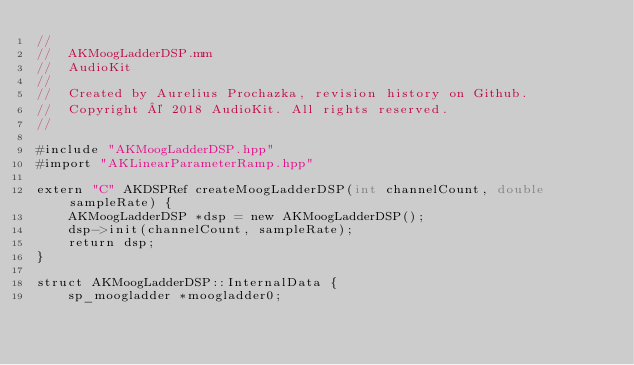<code> <loc_0><loc_0><loc_500><loc_500><_ObjectiveC_>//
//  AKMoogLadderDSP.mm
//  AudioKit
//
//  Created by Aurelius Prochazka, revision history on Github.
//  Copyright © 2018 AudioKit. All rights reserved.
//

#include "AKMoogLadderDSP.hpp"
#import "AKLinearParameterRamp.hpp"

extern "C" AKDSPRef createMoogLadderDSP(int channelCount, double sampleRate) {
    AKMoogLadderDSP *dsp = new AKMoogLadderDSP();
    dsp->init(channelCount, sampleRate);
    return dsp;
}

struct AKMoogLadderDSP::InternalData {
    sp_moogladder *moogladder0;</code> 